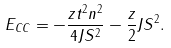<formula> <loc_0><loc_0><loc_500><loc_500>E _ { C C } = - \frac { z t ^ { 2 } n ^ { 2 } } { 4 J S ^ { 2 } } - \frac { z } { 2 } J S ^ { 2 } .</formula> 